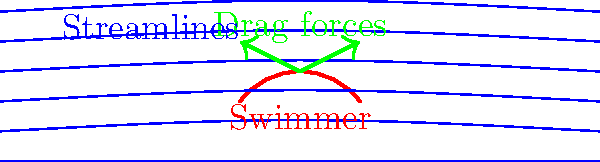A competitive swimmer is practicing their freestyle stroke in a pool. Based on the fluid dynamics visualization above, which shows streamlines and drag forces, what modification to the swimmer's technique would likely result in the greatest reduction of drag force? To answer this question, let's analyze the fluid dynamics visualization:

1. Streamlines: The blue curves represent the flow of water around the swimmer's body. They show how water particles move past the swimmer.

2. Swimmer's body: The red curve represents the swimmer's body profile in the water.

3. Drag forces: The green arrows indicate the direction and relative magnitude of drag forces acting on the swimmer.

4. Analyzing the diagram:
   a) The streamlines are closer together near the swimmer's body, indicating higher water velocity in these areas.
   b) The drag force arrows point backward and slightly upward, showing that drag acts against the swimmer's forward motion and tends to lift them slightly.

5. To reduce drag:
   a) Minimize the cross-sectional area perpendicular to the direction of motion.
   b) Create a more streamlined body position to allow water to flow more smoothly around the body.
   c) Reduce the separation of flow, which creates turbulence and increases drag.

6. The most effective modification would be to:
   - Keep the body as horizontal and streamlined as possible.
   - This would align the body with the streamlines, reducing the cross-sectional area and minimizing flow separation.

Therefore, the greatest reduction in drag force would likely result from the swimmer maintaining a more horizontal, streamlined body position in the water.
Answer: Maintain a more horizontal, streamlined body position 